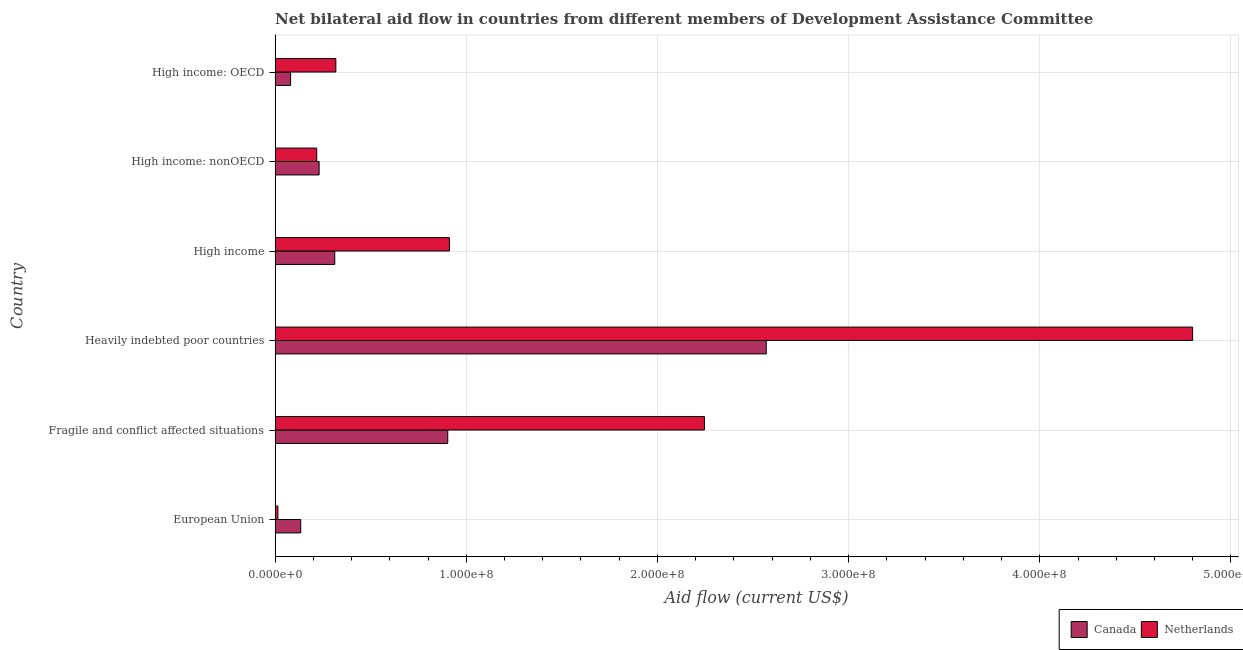How many different coloured bars are there?
Your response must be concise. 2. Are the number of bars per tick equal to the number of legend labels?
Make the answer very short. Yes. What is the label of the 5th group of bars from the top?
Ensure brevity in your answer.  Fragile and conflict affected situations. What is the amount of aid given by canada in European Union?
Your answer should be very brief. 1.34e+07. Across all countries, what is the maximum amount of aid given by canada?
Your answer should be very brief. 2.57e+08. Across all countries, what is the minimum amount of aid given by canada?
Make the answer very short. 8.13e+06. In which country was the amount of aid given by canada maximum?
Keep it short and to the point. Heavily indebted poor countries. What is the total amount of aid given by netherlands in the graph?
Your answer should be compact. 8.51e+08. What is the difference between the amount of aid given by netherlands in European Union and that in Fragile and conflict affected situations?
Give a very brief answer. -2.23e+08. What is the difference between the amount of aid given by canada in High income: nonOECD and the amount of aid given by netherlands in European Union?
Offer a terse response. 2.16e+07. What is the average amount of aid given by netherlands per country?
Offer a terse response. 1.42e+08. What is the difference between the amount of aid given by netherlands and amount of aid given by canada in Heavily indebted poor countries?
Provide a short and direct response. 2.23e+08. What is the ratio of the amount of aid given by canada in Fragile and conflict affected situations to that in High income: OECD?
Ensure brevity in your answer.  11.11. Is the amount of aid given by canada in European Union less than that in High income: OECD?
Offer a very short reply. No. Is the difference between the amount of aid given by canada in Fragile and conflict affected situations and Heavily indebted poor countries greater than the difference between the amount of aid given by netherlands in Fragile and conflict affected situations and Heavily indebted poor countries?
Your answer should be compact. Yes. What is the difference between the highest and the second highest amount of aid given by netherlands?
Make the answer very short. 2.55e+08. What is the difference between the highest and the lowest amount of aid given by netherlands?
Offer a terse response. 4.78e+08. In how many countries, is the amount of aid given by canada greater than the average amount of aid given by canada taken over all countries?
Keep it short and to the point. 2. Is the sum of the amount of aid given by netherlands in Fragile and conflict affected situations and High income greater than the maximum amount of aid given by canada across all countries?
Your answer should be very brief. Yes. What does the 2nd bar from the top in High income: OECD represents?
Give a very brief answer. Canada. What does the 1st bar from the bottom in European Union represents?
Your response must be concise. Canada. How many bars are there?
Provide a short and direct response. 12. Are all the bars in the graph horizontal?
Make the answer very short. Yes. How many countries are there in the graph?
Give a very brief answer. 6. What is the difference between two consecutive major ticks on the X-axis?
Your answer should be compact. 1.00e+08. Are the values on the major ticks of X-axis written in scientific E-notation?
Offer a terse response. Yes. How many legend labels are there?
Provide a short and direct response. 2. What is the title of the graph?
Provide a succinct answer. Net bilateral aid flow in countries from different members of Development Assistance Committee. Does "Male entrants" appear as one of the legend labels in the graph?
Provide a succinct answer. No. What is the label or title of the X-axis?
Provide a short and direct response. Aid flow (current US$). What is the label or title of the Y-axis?
Your answer should be very brief. Country. What is the Aid flow (current US$) of Canada in European Union?
Provide a short and direct response. 1.34e+07. What is the Aid flow (current US$) of Netherlands in European Union?
Provide a short and direct response. 1.48e+06. What is the Aid flow (current US$) in Canada in Fragile and conflict affected situations?
Keep it short and to the point. 9.03e+07. What is the Aid flow (current US$) in Netherlands in Fragile and conflict affected situations?
Your answer should be compact. 2.25e+08. What is the Aid flow (current US$) of Canada in Heavily indebted poor countries?
Provide a short and direct response. 2.57e+08. What is the Aid flow (current US$) of Netherlands in Heavily indebted poor countries?
Keep it short and to the point. 4.80e+08. What is the Aid flow (current US$) in Canada in High income?
Ensure brevity in your answer.  3.12e+07. What is the Aid flow (current US$) of Netherlands in High income?
Ensure brevity in your answer.  9.12e+07. What is the Aid flow (current US$) in Canada in High income: nonOECD?
Offer a very short reply. 2.30e+07. What is the Aid flow (current US$) of Netherlands in High income: nonOECD?
Your answer should be very brief. 2.18e+07. What is the Aid flow (current US$) of Canada in High income: OECD?
Your answer should be very brief. 8.13e+06. What is the Aid flow (current US$) in Netherlands in High income: OECD?
Offer a terse response. 3.18e+07. Across all countries, what is the maximum Aid flow (current US$) in Canada?
Offer a terse response. 2.57e+08. Across all countries, what is the maximum Aid flow (current US$) in Netherlands?
Your response must be concise. 4.80e+08. Across all countries, what is the minimum Aid flow (current US$) in Canada?
Keep it short and to the point. 8.13e+06. Across all countries, what is the minimum Aid flow (current US$) in Netherlands?
Ensure brevity in your answer.  1.48e+06. What is the total Aid flow (current US$) of Canada in the graph?
Ensure brevity in your answer.  4.23e+08. What is the total Aid flow (current US$) in Netherlands in the graph?
Your answer should be compact. 8.51e+08. What is the difference between the Aid flow (current US$) of Canada in European Union and that in Fragile and conflict affected situations?
Ensure brevity in your answer.  -7.69e+07. What is the difference between the Aid flow (current US$) in Netherlands in European Union and that in Fragile and conflict affected situations?
Offer a terse response. -2.23e+08. What is the difference between the Aid flow (current US$) of Canada in European Union and that in Heavily indebted poor countries?
Your answer should be compact. -2.44e+08. What is the difference between the Aid flow (current US$) of Netherlands in European Union and that in Heavily indebted poor countries?
Your response must be concise. -4.78e+08. What is the difference between the Aid flow (current US$) in Canada in European Union and that in High income?
Your answer should be very brief. -1.78e+07. What is the difference between the Aid flow (current US$) in Netherlands in European Union and that in High income?
Your answer should be very brief. -8.97e+07. What is the difference between the Aid flow (current US$) in Canada in European Union and that in High income: nonOECD?
Provide a short and direct response. -9.63e+06. What is the difference between the Aid flow (current US$) of Netherlands in European Union and that in High income: nonOECD?
Provide a short and direct response. -2.03e+07. What is the difference between the Aid flow (current US$) of Canada in European Union and that in High income: OECD?
Provide a succinct answer. 5.28e+06. What is the difference between the Aid flow (current US$) in Netherlands in European Union and that in High income: OECD?
Your answer should be very brief. -3.03e+07. What is the difference between the Aid flow (current US$) of Canada in Fragile and conflict affected situations and that in Heavily indebted poor countries?
Ensure brevity in your answer.  -1.67e+08. What is the difference between the Aid flow (current US$) of Netherlands in Fragile and conflict affected situations and that in Heavily indebted poor countries?
Provide a succinct answer. -2.55e+08. What is the difference between the Aid flow (current US$) of Canada in Fragile and conflict affected situations and that in High income?
Offer a very short reply. 5.91e+07. What is the difference between the Aid flow (current US$) of Netherlands in Fragile and conflict affected situations and that in High income?
Your answer should be very brief. 1.33e+08. What is the difference between the Aid flow (current US$) in Canada in Fragile and conflict affected situations and that in High income: nonOECD?
Your answer should be very brief. 6.73e+07. What is the difference between the Aid flow (current US$) in Netherlands in Fragile and conflict affected situations and that in High income: nonOECD?
Keep it short and to the point. 2.03e+08. What is the difference between the Aid flow (current US$) in Canada in Fragile and conflict affected situations and that in High income: OECD?
Your answer should be compact. 8.22e+07. What is the difference between the Aid flow (current US$) in Netherlands in Fragile and conflict affected situations and that in High income: OECD?
Provide a succinct answer. 1.93e+08. What is the difference between the Aid flow (current US$) of Canada in Heavily indebted poor countries and that in High income?
Your response must be concise. 2.26e+08. What is the difference between the Aid flow (current US$) of Netherlands in Heavily indebted poor countries and that in High income?
Make the answer very short. 3.89e+08. What is the difference between the Aid flow (current US$) in Canada in Heavily indebted poor countries and that in High income: nonOECD?
Offer a very short reply. 2.34e+08. What is the difference between the Aid flow (current US$) of Netherlands in Heavily indebted poor countries and that in High income: nonOECD?
Offer a terse response. 4.58e+08. What is the difference between the Aid flow (current US$) in Canada in Heavily indebted poor countries and that in High income: OECD?
Your response must be concise. 2.49e+08. What is the difference between the Aid flow (current US$) in Netherlands in Heavily indebted poor countries and that in High income: OECD?
Provide a succinct answer. 4.48e+08. What is the difference between the Aid flow (current US$) of Canada in High income and that in High income: nonOECD?
Offer a terse response. 8.18e+06. What is the difference between the Aid flow (current US$) in Netherlands in High income and that in High income: nonOECD?
Provide a succinct answer. 6.94e+07. What is the difference between the Aid flow (current US$) in Canada in High income and that in High income: OECD?
Your answer should be compact. 2.31e+07. What is the difference between the Aid flow (current US$) in Netherlands in High income and that in High income: OECD?
Make the answer very short. 5.94e+07. What is the difference between the Aid flow (current US$) in Canada in High income: nonOECD and that in High income: OECD?
Provide a succinct answer. 1.49e+07. What is the difference between the Aid flow (current US$) in Netherlands in High income: nonOECD and that in High income: OECD?
Ensure brevity in your answer.  -9.99e+06. What is the difference between the Aid flow (current US$) of Canada in European Union and the Aid flow (current US$) of Netherlands in Fragile and conflict affected situations?
Give a very brief answer. -2.11e+08. What is the difference between the Aid flow (current US$) in Canada in European Union and the Aid flow (current US$) in Netherlands in Heavily indebted poor countries?
Your answer should be compact. -4.67e+08. What is the difference between the Aid flow (current US$) in Canada in European Union and the Aid flow (current US$) in Netherlands in High income?
Offer a very short reply. -7.78e+07. What is the difference between the Aid flow (current US$) in Canada in European Union and the Aid flow (current US$) in Netherlands in High income: nonOECD?
Offer a very short reply. -8.38e+06. What is the difference between the Aid flow (current US$) of Canada in European Union and the Aid flow (current US$) of Netherlands in High income: OECD?
Offer a terse response. -1.84e+07. What is the difference between the Aid flow (current US$) in Canada in Fragile and conflict affected situations and the Aid flow (current US$) in Netherlands in Heavily indebted poor countries?
Ensure brevity in your answer.  -3.90e+08. What is the difference between the Aid flow (current US$) of Canada in Fragile and conflict affected situations and the Aid flow (current US$) of Netherlands in High income?
Provide a succinct answer. -8.80e+05. What is the difference between the Aid flow (current US$) of Canada in Fragile and conflict affected situations and the Aid flow (current US$) of Netherlands in High income: nonOECD?
Provide a succinct answer. 6.85e+07. What is the difference between the Aid flow (current US$) in Canada in Fragile and conflict affected situations and the Aid flow (current US$) in Netherlands in High income: OECD?
Keep it short and to the point. 5.85e+07. What is the difference between the Aid flow (current US$) of Canada in Heavily indebted poor countries and the Aid flow (current US$) of Netherlands in High income?
Your answer should be very brief. 1.66e+08. What is the difference between the Aid flow (current US$) in Canada in Heavily indebted poor countries and the Aid flow (current US$) in Netherlands in High income: nonOECD?
Make the answer very short. 2.35e+08. What is the difference between the Aid flow (current US$) of Canada in Heavily indebted poor countries and the Aid flow (current US$) of Netherlands in High income: OECD?
Your answer should be compact. 2.25e+08. What is the difference between the Aid flow (current US$) in Canada in High income and the Aid flow (current US$) in Netherlands in High income: nonOECD?
Offer a terse response. 9.43e+06. What is the difference between the Aid flow (current US$) in Canada in High income and the Aid flow (current US$) in Netherlands in High income: OECD?
Make the answer very short. -5.60e+05. What is the difference between the Aid flow (current US$) in Canada in High income: nonOECD and the Aid flow (current US$) in Netherlands in High income: OECD?
Provide a short and direct response. -8.74e+06. What is the average Aid flow (current US$) in Canada per country?
Provide a short and direct response. 7.05e+07. What is the average Aid flow (current US$) of Netherlands per country?
Your answer should be compact. 1.42e+08. What is the difference between the Aid flow (current US$) of Canada and Aid flow (current US$) of Netherlands in European Union?
Your response must be concise. 1.19e+07. What is the difference between the Aid flow (current US$) in Canada and Aid flow (current US$) in Netherlands in Fragile and conflict affected situations?
Give a very brief answer. -1.34e+08. What is the difference between the Aid flow (current US$) of Canada and Aid flow (current US$) of Netherlands in Heavily indebted poor countries?
Provide a succinct answer. -2.23e+08. What is the difference between the Aid flow (current US$) in Canada and Aid flow (current US$) in Netherlands in High income?
Offer a very short reply. -6.00e+07. What is the difference between the Aid flow (current US$) in Canada and Aid flow (current US$) in Netherlands in High income: nonOECD?
Your response must be concise. 1.25e+06. What is the difference between the Aid flow (current US$) in Canada and Aid flow (current US$) in Netherlands in High income: OECD?
Offer a very short reply. -2.36e+07. What is the ratio of the Aid flow (current US$) in Canada in European Union to that in Fragile and conflict affected situations?
Offer a very short reply. 0.15. What is the ratio of the Aid flow (current US$) of Netherlands in European Union to that in Fragile and conflict affected situations?
Give a very brief answer. 0.01. What is the ratio of the Aid flow (current US$) of Canada in European Union to that in Heavily indebted poor countries?
Your answer should be very brief. 0.05. What is the ratio of the Aid flow (current US$) of Netherlands in European Union to that in Heavily indebted poor countries?
Your answer should be compact. 0. What is the ratio of the Aid flow (current US$) of Canada in European Union to that in High income?
Give a very brief answer. 0.43. What is the ratio of the Aid flow (current US$) of Netherlands in European Union to that in High income?
Your answer should be compact. 0.02. What is the ratio of the Aid flow (current US$) of Canada in European Union to that in High income: nonOECD?
Give a very brief answer. 0.58. What is the ratio of the Aid flow (current US$) in Netherlands in European Union to that in High income: nonOECD?
Your answer should be very brief. 0.07. What is the ratio of the Aid flow (current US$) of Canada in European Union to that in High income: OECD?
Provide a succinct answer. 1.65. What is the ratio of the Aid flow (current US$) of Netherlands in European Union to that in High income: OECD?
Your answer should be compact. 0.05. What is the ratio of the Aid flow (current US$) of Canada in Fragile and conflict affected situations to that in Heavily indebted poor countries?
Give a very brief answer. 0.35. What is the ratio of the Aid flow (current US$) in Netherlands in Fragile and conflict affected situations to that in Heavily indebted poor countries?
Ensure brevity in your answer.  0.47. What is the ratio of the Aid flow (current US$) in Canada in Fragile and conflict affected situations to that in High income?
Your response must be concise. 2.89. What is the ratio of the Aid flow (current US$) in Netherlands in Fragile and conflict affected situations to that in High income?
Keep it short and to the point. 2.46. What is the ratio of the Aid flow (current US$) in Canada in Fragile and conflict affected situations to that in High income: nonOECD?
Ensure brevity in your answer.  3.92. What is the ratio of the Aid flow (current US$) of Netherlands in Fragile and conflict affected situations to that in High income: nonOECD?
Provide a succinct answer. 10.31. What is the ratio of the Aid flow (current US$) of Canada in Fragile and conflict affected situations to that in High income: OECD?
Provide a succinct answer. 11.11. What is the ratio of the Aid flow (current US$) in Netherlands in Fragile and conflict affected situations to that in High income: OECD?
Your answer should be compact. 7.07. What is the ratio of the Aid flow (current US$) in Canada in Heavily indebted poor countries to that in High income?
Provide a short and direct response. 8.23. What is the ratio of the Aid flow (current US$) of Netherlands in Heavily indebted poor countries to that in High income?
Keep it short and to the point. 5.26. What is the ratio of the Aid flow (current US$) of Canada in Heavily indebted poor countries to that in High income: nonOECD?
Provide a short and direct response. 11.15. What is the ratio of the Aid flow (current US$) of Netherlands in Heavily indebted poor countries to that in High income: nonOECD?
Provide a succinct answer. 22.03. What is the ratio of the Aid flow (current US$) of Canada in Heavily indebted poor countries to that in High income: OECD?
Provide a short and direct response. 31.6. What is the ratio of the Aid flow (current US$) of Netherlands in Heavily indebted poor countries to that in High income: OECD?
Keep it short and to the point. 15.1. What is the ratio of the Aid flow (current US$) in Canada in High income to that in High income: nonOECD?
Offer a terse response. 1.35. What is the ratio of the Aid flow (current US$) of Netherlands in High income to that in High income: nonOECD?
Provide a succinct answer. 4.18. What is the ratio of the Aid flow (current US$) in Canada in High income to that in High income: OECD?
Provide a succinct answer. 3.84. What is the ratio of the Aid flow (current US$) in Netherlands in High income to that in High income: OECD?
Keep it short and to the point. 2.87. What is the ratio of the Aid flow (current US$) of Canada in High income: nonOECD to that in High income: OECD?
Provide a short and direct response. 2.83. What is the ratio of the Aid flow (current US$) in Netherlands in High income: nonOECD to that in High income: OECD?
Provide a short and direct response. 0.69. What is the difference between the highest and the second highest Aid flow (current US$) in Canada?
Your response must be concise. 1.67e+08. What is the difference between the highest and the second highest Aid flow (current US$) in Netherlands?
Offer a very short reply. 2.55e+08. What is the difference between the highest and the lowest Aid flow (current US$) of Canada?
Offer a very short reply. 2.49e+08. What is the difference between the highest and the lowest Aid flow (current US$) in Netherlands?
Offer a terse response. 4.78e+08. 